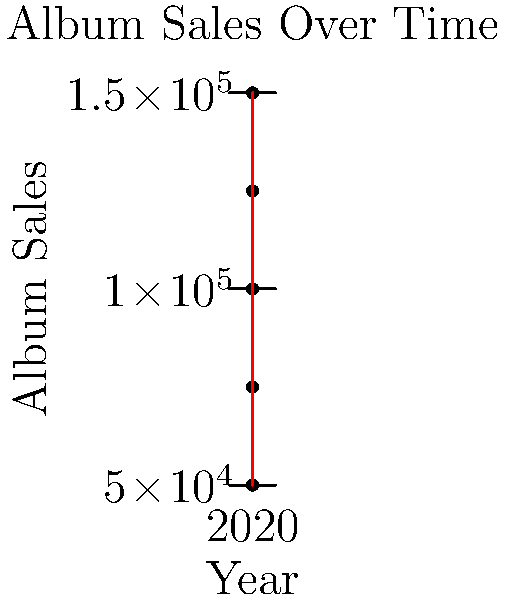Looking at the graph of your album sales over the past 5 years, in which year did you experience the highest sales? What was the approximate number of albums sold in that year? To answer this question, we need to analyze the line chart showing album sales over time:

1. The x-axis represents the years from 2019 to 2023.
2. The y-axis represents the number of album sales.
3. Each point on the graph represents the sales for a specific year.
4. We need to find the highest point on the graph, which corresponds to the year with the highest sales.

Looking at the graph:
- 2019: Approximately 50,000 sales
- 2020: Approximately 75,000 sales
- 2021: Approximately 100,000 sales
- 2022: Highest point, approximately 150,000 sales
- 2023: Slight decrease, approximately 125,000 sales

The highest point on the graph corresponds to the year 2022, with sales reaching approximately 150,000 albums.
Answer: 2022, 150,000 albums 